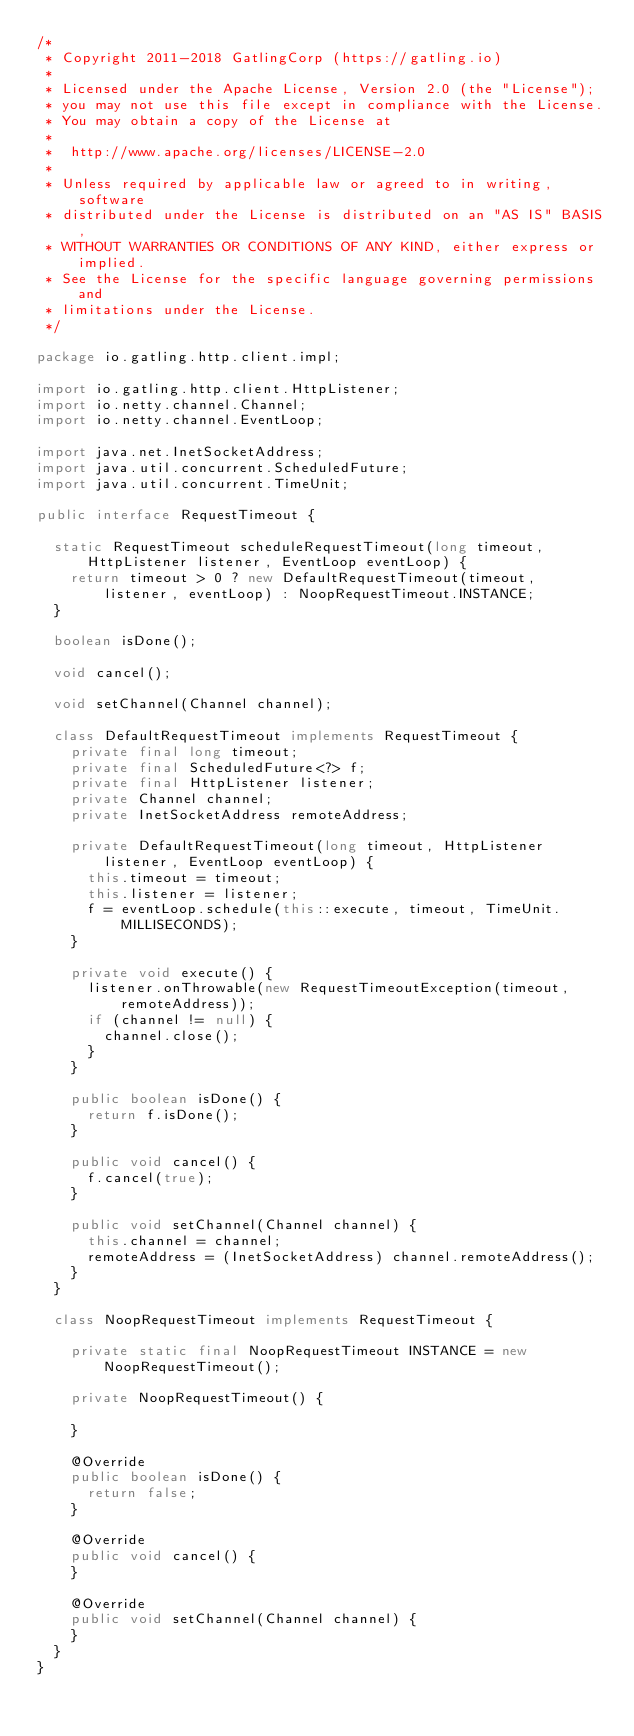<code> <loc_0><loc_0><loc_500><loc_500><_Java_>/*
 * Copyright 2011-2018 GatlingCorp (https://gatling.io)
 *
 * Licensed under the Apache License, Version 2.0 (the "License");
 * you may not use this file except in compliance with the License.
 * You may obtain a copy of the License at
 *
 *  http://www.apache.org/licenses/LICENSE-2.0
 *
 * Unless required by applicable law or agreed to in writing, software
 * distributed under the License is distributed on an "AS IS" BASIS,
 * WITHOUT WARRANTIES OR CONDITIONS OF ANY KIND, either express or implied.
 * See the License for the specific language governing permissions and
 * limitations under the License.
 */

package io.gatling.http.client.impl;

import io.gatling.http.client.HttpListener;
import io.netty.channel.Channel;
import io.netty.channel.EventLoop;

import java.net.InetSocketAddress;
import java.util.concurrent.ScheduledFuture;
import java.util.concurrent.TimeUnit;

public interface RequestTimeout {

  static RequestTimeout scheduleRequestTimeout(long timeout, HttpListener listener, EventLoop eventLoop) {
    return timeout > 0 ? new DefaultRequestTimeout(timeout, listener, eventLoop) : NoopRequestTimeout.INSTANCE;
  }

  boolean isDone();

  void cancel();

  void setChannel(Channel channel);

  class DefaultRequestTimeout implements RequestTimeout {
    private final long timeout;
    private final ScheduledFuture<?> f;
    private final HttpListener listener;
    private Channel channel;
    private InetSocketAddress remoteAddress;

    private DefaultRequestTimeout(long timeout, HttpListener listener, EventLoop eventLoop) {
      this.timeout = timeout;
      this.listener = listener;
      f = eventLoop.schedule(this::execute, timeout, TimeUnit.MILLISECONDS);
    }

    private void execute() {
      listener.onThrowable(new RequestTimeoutException(timeout, remoteAddress));
      if (channel != null) {
        channel.close();
      }
    }

    public boolean isDone() {
      return f.isDone();
    }

    public void cancel() {
      f.cancel(true);
    }

    public void setChannel(Channel channel) {
      this.channel = channel;
      remoteAddress = (InetSocketAddress) channel.remoteAddress();
    }
  }

  class NoopRequestTimeout implements RequestTimeout {

    private static final NoopRequestTimeout INSTANCE = new NoopRequestTimeout();

    private NoopRequestTimeout() {

    }

    @Override
    public boolean isDone() {
      return false;
    }

    @Override
    public void cancel() {
    }

    @Override
    public void setChannel(Channel channel) {
    }
  }
}
</code> 